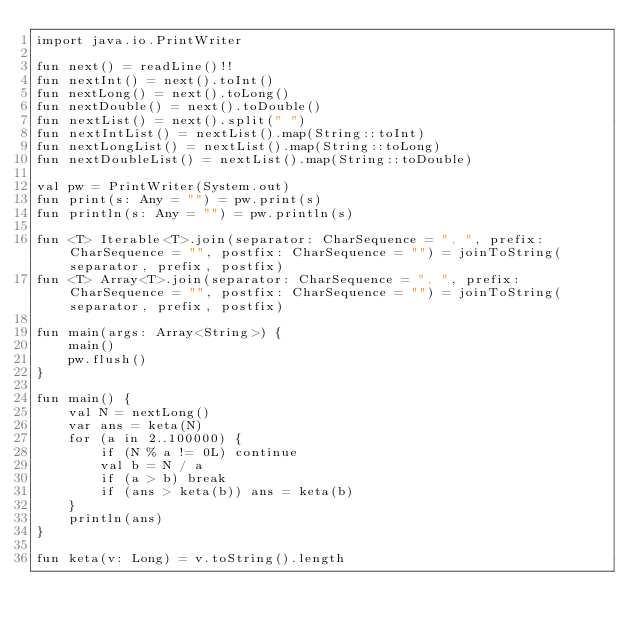Convert code to text. <code><loc_0><loc_0><loc_500><loc_500><_Kotlin_>import java.io.PrintWriter

fun next() = readLine()!!
fun nextInt() = next().toInt()
fun nextLong() = next().toLong()
fun nextDouble() = next().toDouble()
fun nextList() = next().split(" ")
fun nextIntList() = nextList().map(String::toInt)
fun nextLongList() = nextList().map(String::toLong)
fun nextDoubleList() = nextList().map(String::toDouble)

val pw = PrintWriter(System.out)
fun print(s: Any = "") = pw.print(s)
fun println(s: Any = "") = pw.println(s)

fun <T> Iterable<T>.join(separator: CharSequence = ", ", prefix: CharSequence = "", postfix: CharSequence = "") = joinToString(separator, prefix, postfix)
fun <T> Array<T>.join(separator: CharSequence = ", ", prefix: CharSequence = "", postfix: CharSequence = "") = joinToString(separator, prefix, postfix)

fun main(args: Array<String>) {
    main()
    pw.flush()
}

fun main() {
    val N = nextLong()
    var ans = keta(N)
    for (a in 2..100000) {
        if (N % a != 0L) continue
        val b = N / a
        if (a > b) break
        if (ans > keta(b)) ans = keta(b)
    }
    println(ans)
}

fun keta(v: Long) = v.toString().length</code> 